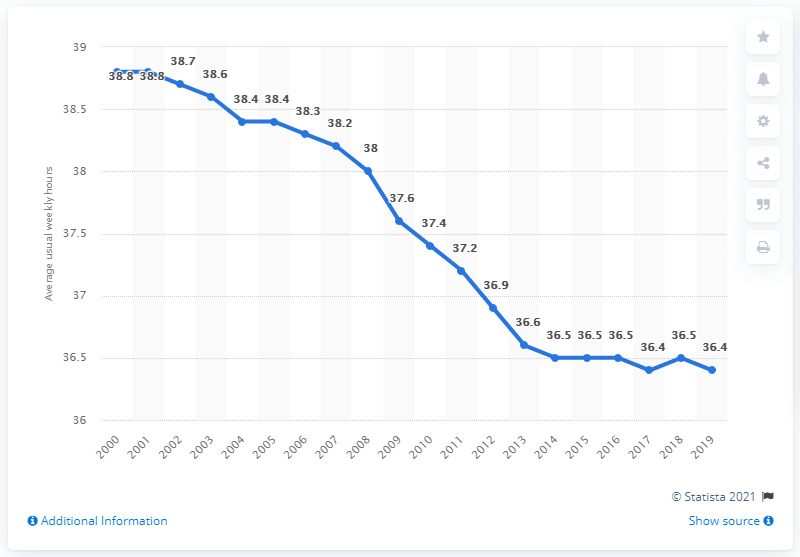Indicate a few pertinent items in this graphic. The blue line declined for approximately 2.4 hours from 2000 to 2019. The data provided for 2017 is 36.4. 